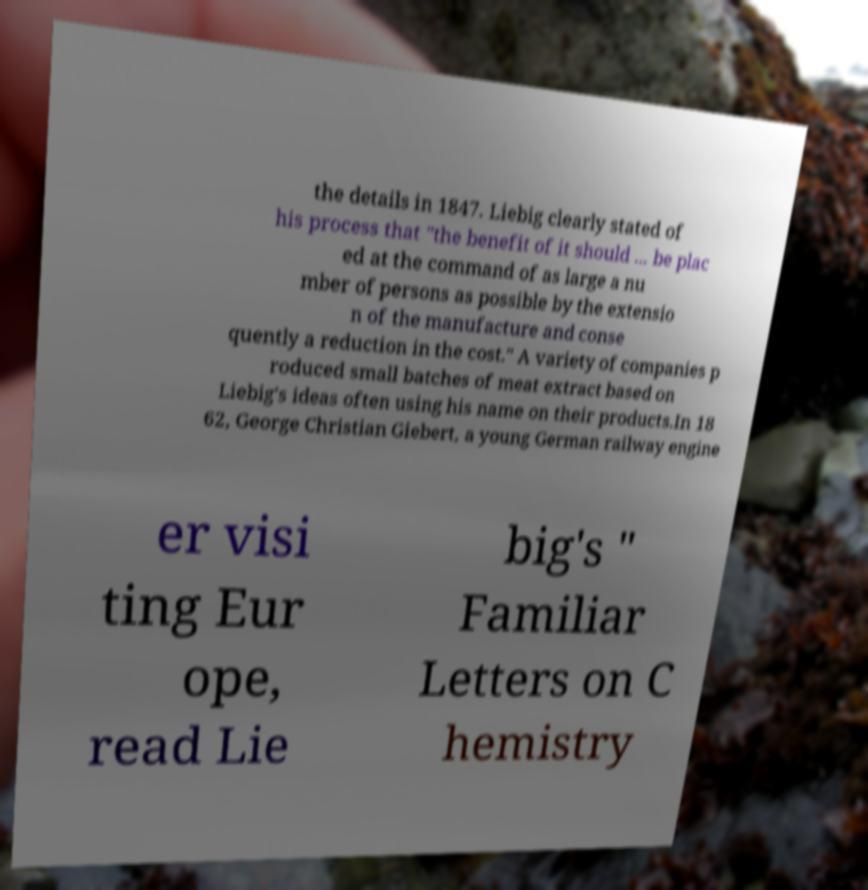Please identify and transcribe the text found in this image. the details in 1847. Liebig clearly stated of his process that "the benefit of it should ... be plac ed at the command of as large a nu mber of persons as possible by the extensio n of the manufacture and conse quently a reduction in the cost." A variety of companies p roduced small batches of meat extract based on Liebig's ideas often using his name on their products.In 18 62, George Christian Giebert, a young German railway engine er visi ting Eur ope, read Lie big's " Familiar Letters on C hemistry 